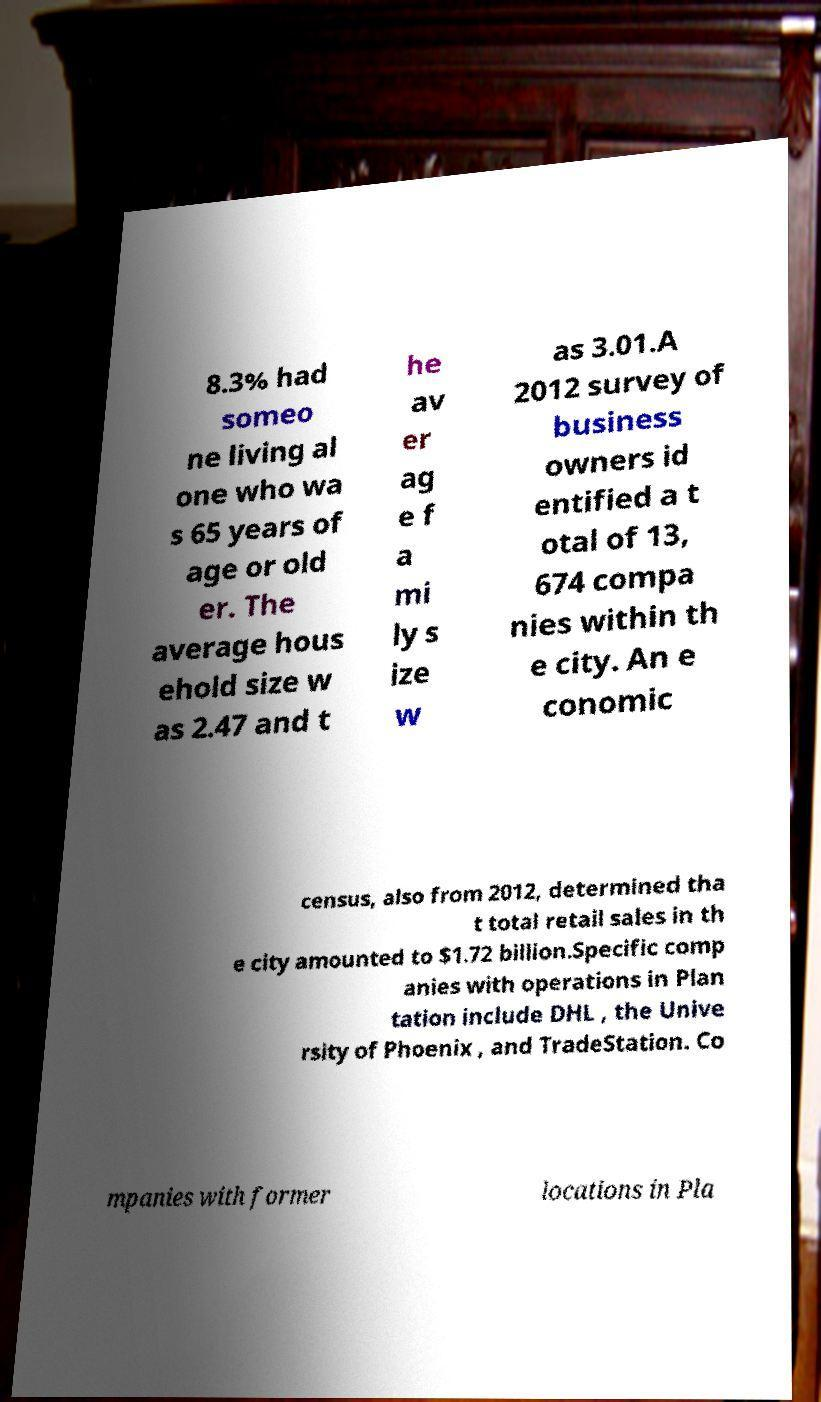Can you read and provide the text displayed in the image?This photo seems to have some interesting text. Can you extract and type it out for me? 8.3% had someo ne living al one who wa s 65 years of age or old er. The average hous ehold size w as 2.47 and t he av er ag e f a mi ly s ize w as 3.01.A 2012 survey of business owners id entified a t otal of 13, 674 compa nies within th e city. An e conomic census, also from 2012, determined tha t total retail sales in th e city amounted to $1.72 billion.Specific comp anies with operations in Plan tation include DHL , the Unive rsity of Phoenix , and TradeStation. Co mpanies with former locations in Pla 